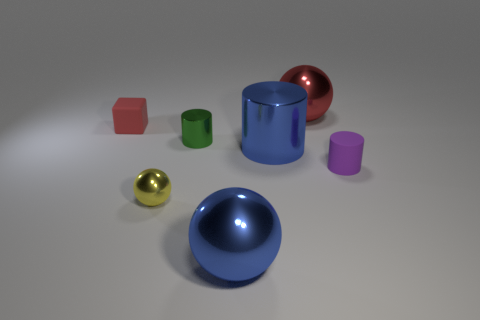Is the shape of the small thing that is to the right of the green metallic object the same as the tiny shiny object that is behind the yellow thing?
Offer a very short reply. Yes. Is the size of the red object that is in front of the red ball the same as the blue metallic ball?
Make the answer very short. No. Are there any small matte things that are to the left of the large metallic ball right of the big blue cylinder?
Provide a succinct answer. Yes. What is the blue cylinder made of?
Your response must be concise. Metal. There is a small red thing; are there any blue shiny things right of it?
Provide a short and direct response. Yes. There is another metal object that is the same shape as the green object; what size is it?
Your response must be concise. Large. Are there an equal number of large shiny balls in front of the blue metallic sphere and purple cylinders that are in front of the big blue cylinder?
Provide a short and direct response. No. How many big red metallic cubes are there?
Your answer should be very brief. 0. Are there more red metallic objects that are right of the small rubber cube than tiny purple metal cubes?
Your answer should be compact. Yes. There is a blue object behind the yellow ball; what is it made of?
Offer a very short reply. Metal. 